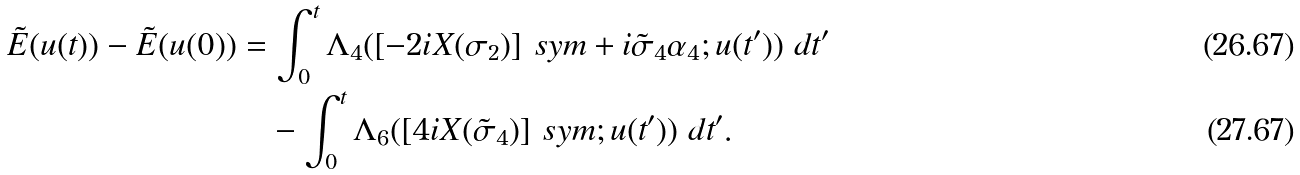Convert formula to latex. <formula><loc_0><loc_0><loc_500><loc_500>\tilde { E } ( u ( t ) ) - \tilde { E } ( u ( 0 ) ) & = \int _ { 0 } ^ { t } \Lambda _ { 4 } ( [ - 2 i X ( \sigma _ { 2 } ) ] _ { \ } s y m + i \tilde { \sigma } _ { 4 } \alpha _ { 4 } ; u ( t ^ { \prime } ) ) \ d t ^ { \prime } \\ & \quad - \int _ { 0 } ^ { t } \Lambda _ { 6 } ( [ 4 i X ( \tilde { \sigma } _ { 4 } ) ] _ { \ } s y m ; u ( t ^ { \prime } ) ) \ d t ^ { \prime } .</formula> 